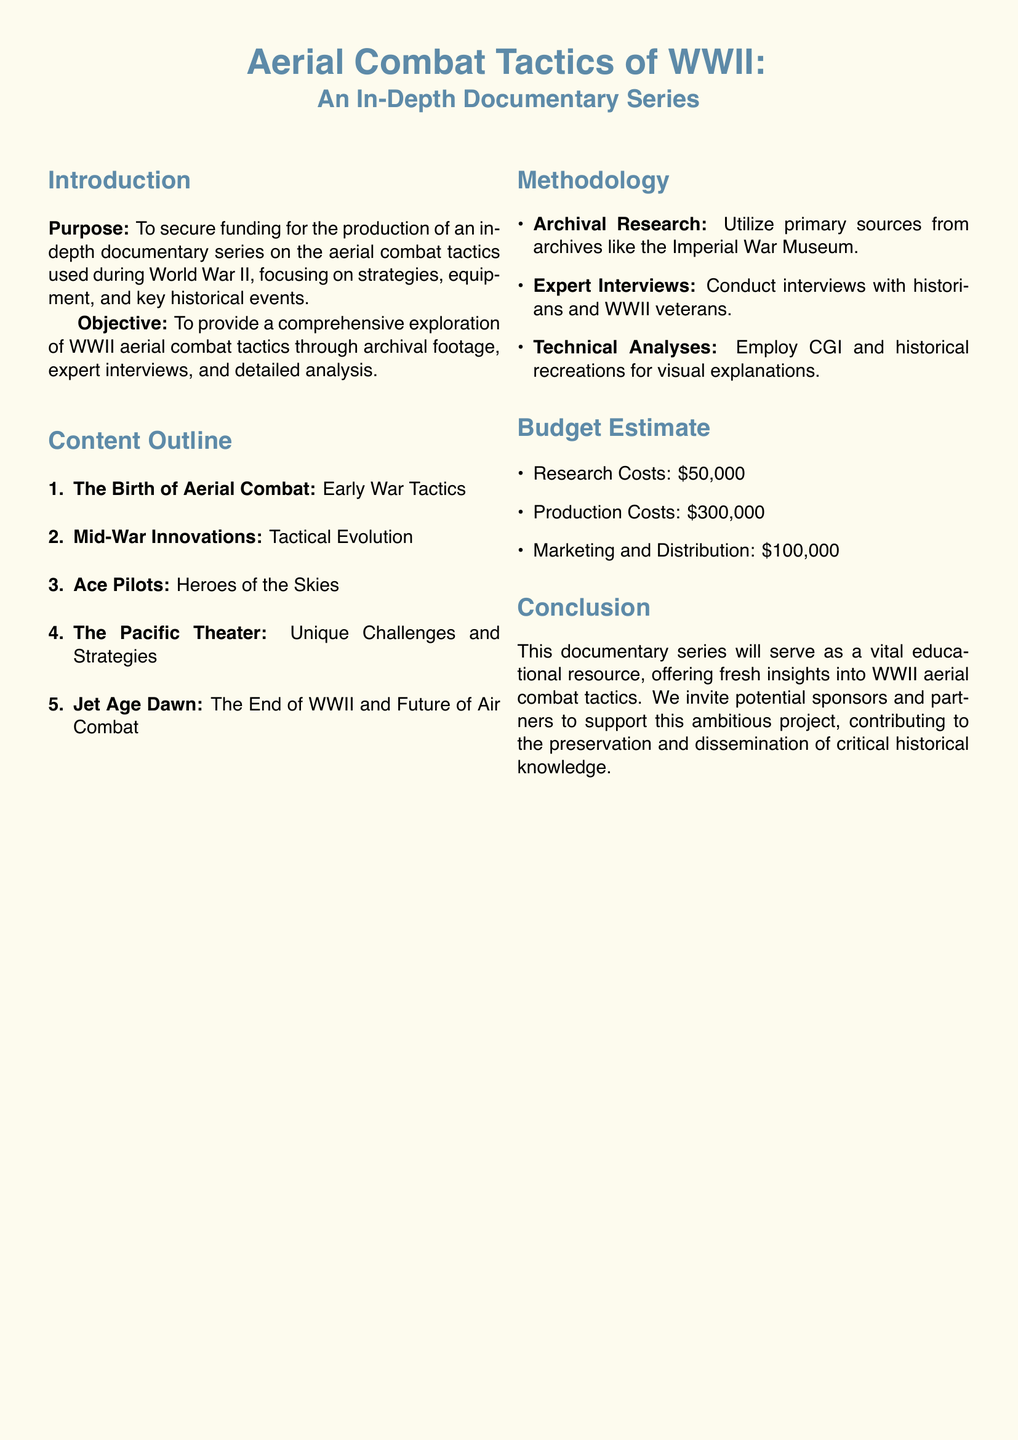What is the purpose of the proposal? The purpose is to secure funding for the production of an in-depth documentary series on the aerial combat tactics used during World War II.
Answer: Secure funding What is the budget estimate for production costs? The document specifies production costs in the budget estimate section.
Answer: $300,000 How many main topics are outlined in the content? The content outline lists the number of main topics to be covered in the series.
Answer: 5 Who will be interviewed for the documentary? The methodology section indicates who will be interviewed.
Answer: Historians and WWII veterans What is the title of the first section in the content outline? The first section in the content outline describes early aerial combat tactics.
Answer: The Birth of Aerial Combat What type of research will be utilized in the project? The methodology section mentions a specific type of research that will be carried out.
Answer: Archival Research What color is used for the document's header text? The document defines a specific color for the header text in the formatting section.
Answer: Airforce blue What is the title of the documentary series? The document presents the title at the top, which summarizes the series' focus.
Answer: Aerial Combat Tactics of WWII 